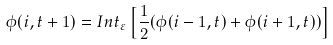Convert formula to latex. <formula><loc_0><loc_0><loc_500><loc_500>\phi ( i , t + 1 ) = I n t _ { \varepsilon } \left [ \frac { 1 } { 2 } ( \phi ( i - 1 , t ) + \phi ( i + 1 , t ) ) \right ]</formula> 